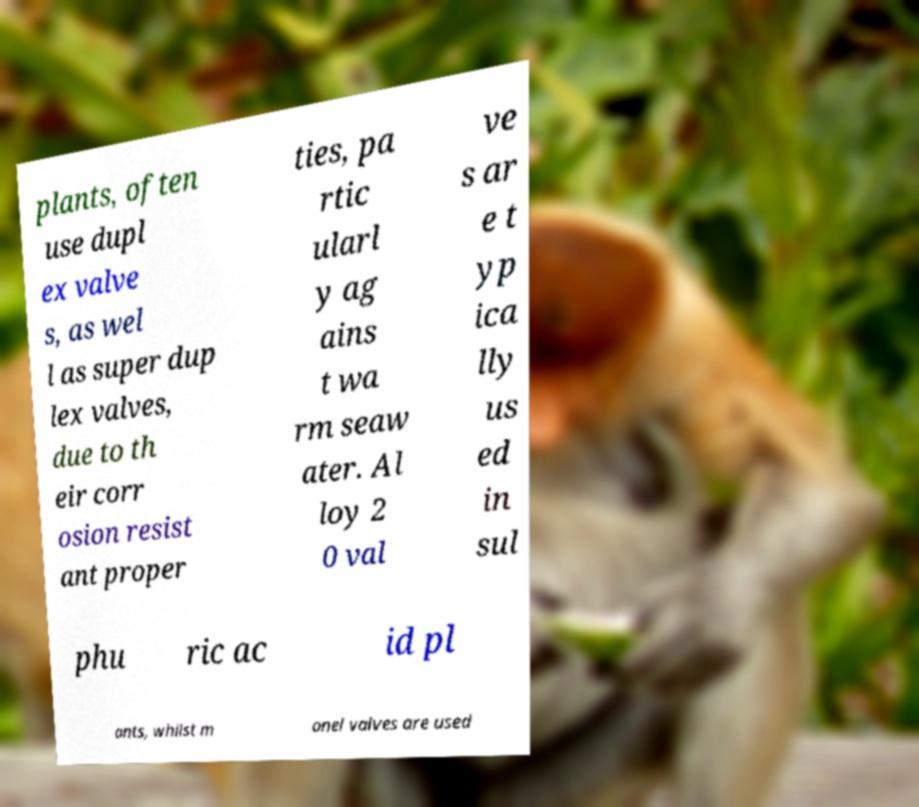Could you assist in decoding the text presented in this image and type it out clearly? plants, often use dupl ex valve s, as wel l as super dup lex valves, due to th eir corr osion resist ant proper ties, pa rtic ularl y ag ains t wa rm seaw ater. Al loy 2 0 val ve s ar e t yp ica lly us ed in sul phu ric ac id pl ants, whilst m onel valves are used 